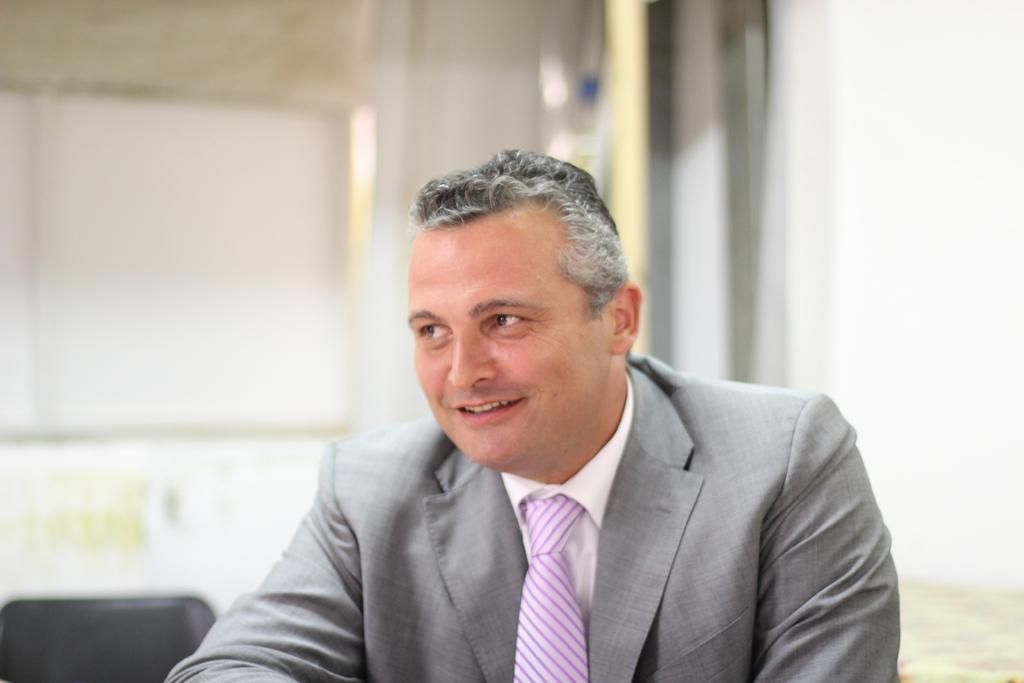Who is present in the image? There is a man in the image. What is the man's facial expression? The man is smiling. Can you describe the background of the image? The background is blurred in the image. Are there any specific objects or features visible in the background? There are a few unspecified things in the background. What type of nail is being hammered by the man in the image? There is no nail or hammer present in the image; it features a man who is smiling. 